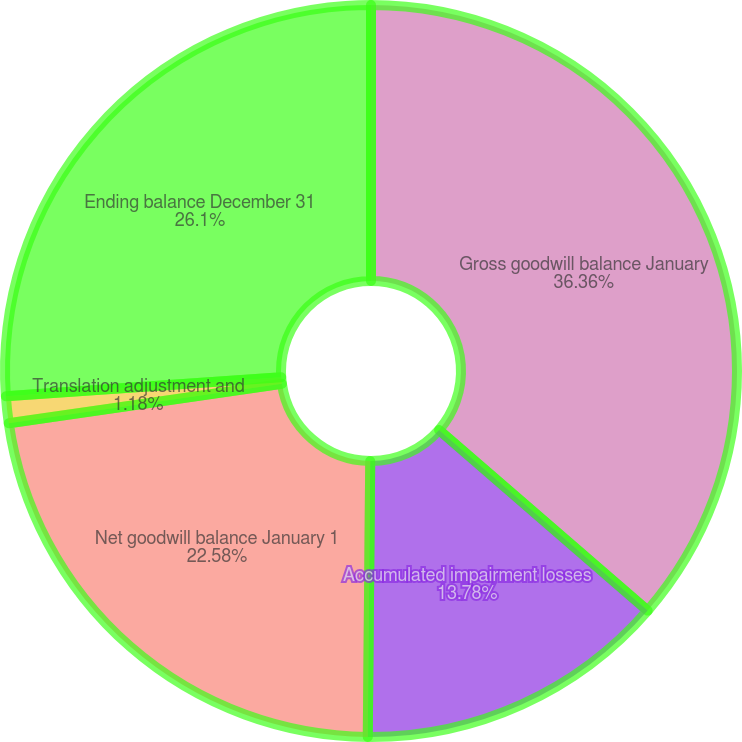<chart> <loc_0><loc_0><loc_500><loc_500><pie_chart><fcel>Gross goodwill balance January<fcel>Accumulated impairment losses<fcel>Net goodwill balance January 1<fcel>Translation adjustment and<fcel>Ending balance December 31<nl><fcel>36.36%<fcel>13.78%<fcel>22.58%<fcel>1.18%<fcel>26.1%<nl></chart> 